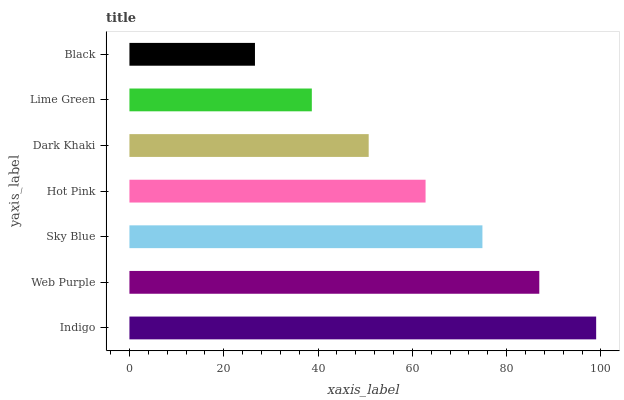Is Black the minimum?
Answer yes or no. Yes. Is Indigo the maximum?
Answer yes or no. Yes. Is Web Purple the minimum?
Answer yes or no. No. Is Web Purple the maximum?
Answer yes or no. No. Is Indigo greater than Web Purple?
Answer yes or no. Yes. Is Web Purple less than Indigo?
Answer yes or no. Yes. Is Web Purple greater than Indigo?
Answer yes or no. No. Is Indigo less than Web Purple?
Answer yes or no. No. Is Hot Pink the high median?
Answer yes or no. Yes. Is Hot Pink the low median?
Answer yes or no. Yes. Is Black the high median?
Answer yes or no. No. Is Sky Blue the low median?
Answer yes or no. No. 